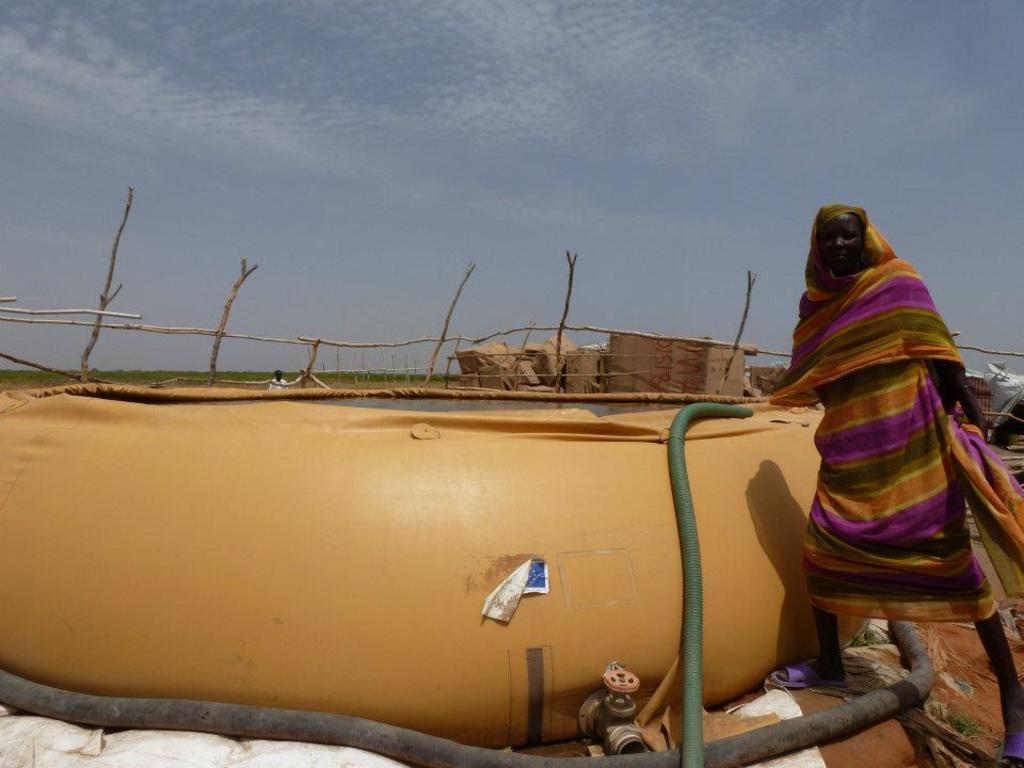How would you summarize this image in a sentence or two? In this image we can see a person wearing dress is standing here, here we can see pipes, tap, yellow color tub in which we can see water, we can see wooden fence, hut and some objects, a person standing here, farmland and the sky with the clouds in the background. 